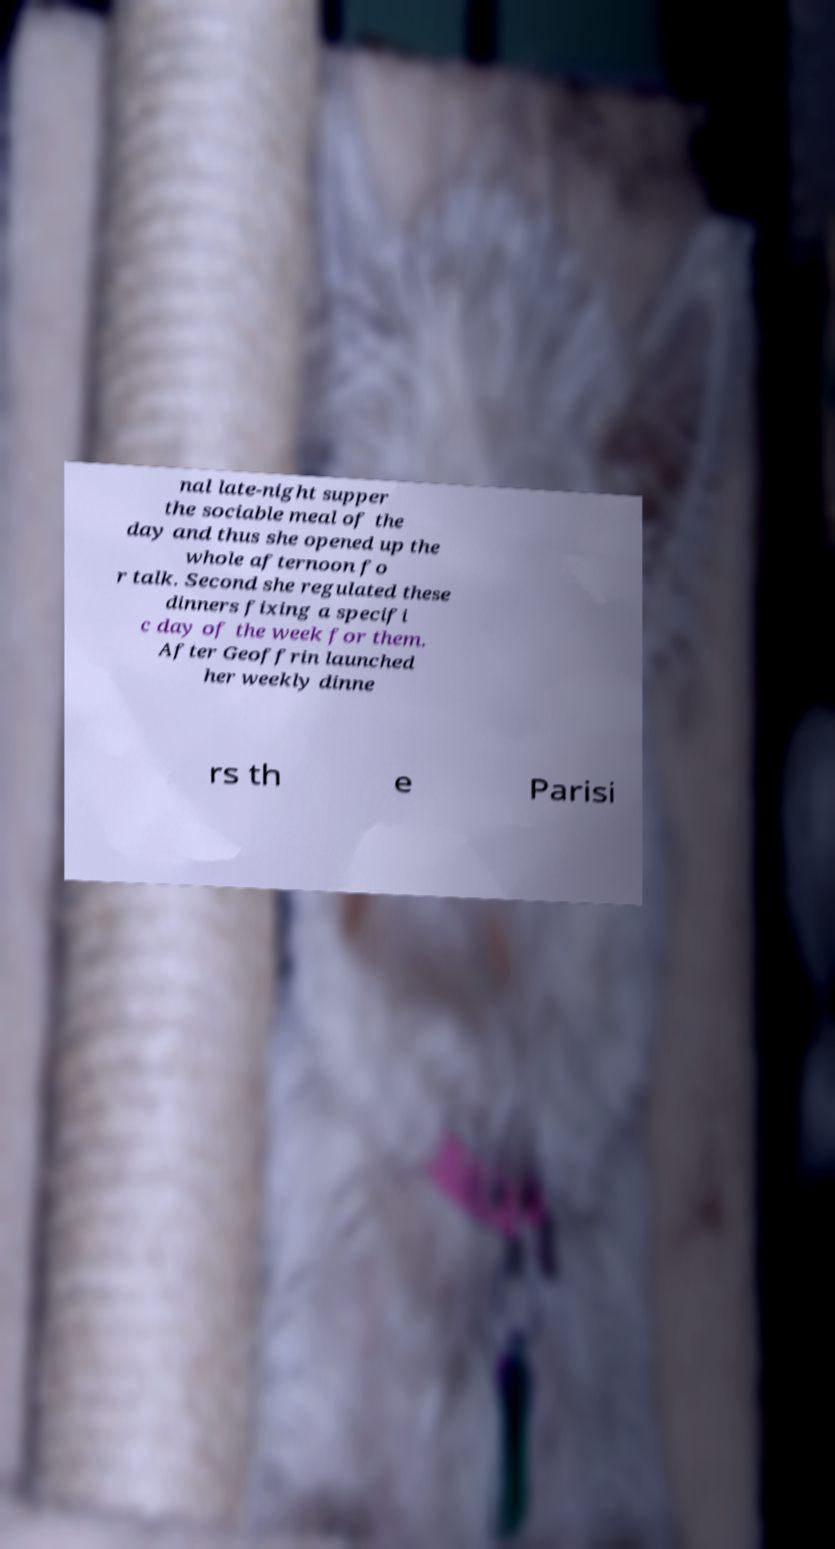Can you read and provide the text displayed in the image?This photo seems to have some interesting text. Can you extract and type it out for me? nal late-night supper the sociable meal of the day and thus she opened up the whole afternoon fo r talk. Second she regulated these dinners fixing a specifi c day of the week for them. After Geoffrin launched her weekly dinne rs th e Parisi 